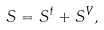<formula> <loc_0><loc_0><loc_500><loc_500>S = S ^ { t } + S ^ { V } ,</formula> 